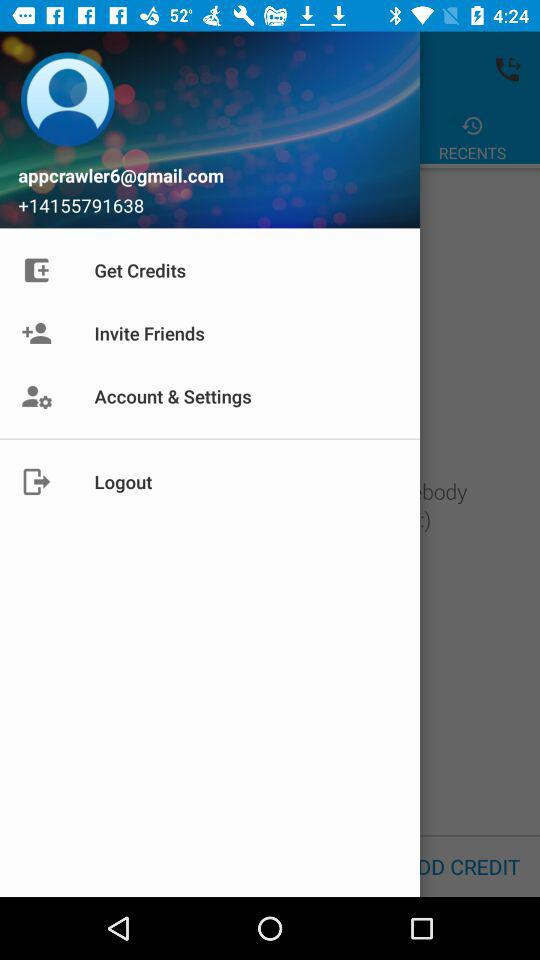What Gmail address is used? The used Gmail address is appcrawler6@gmail.com. 